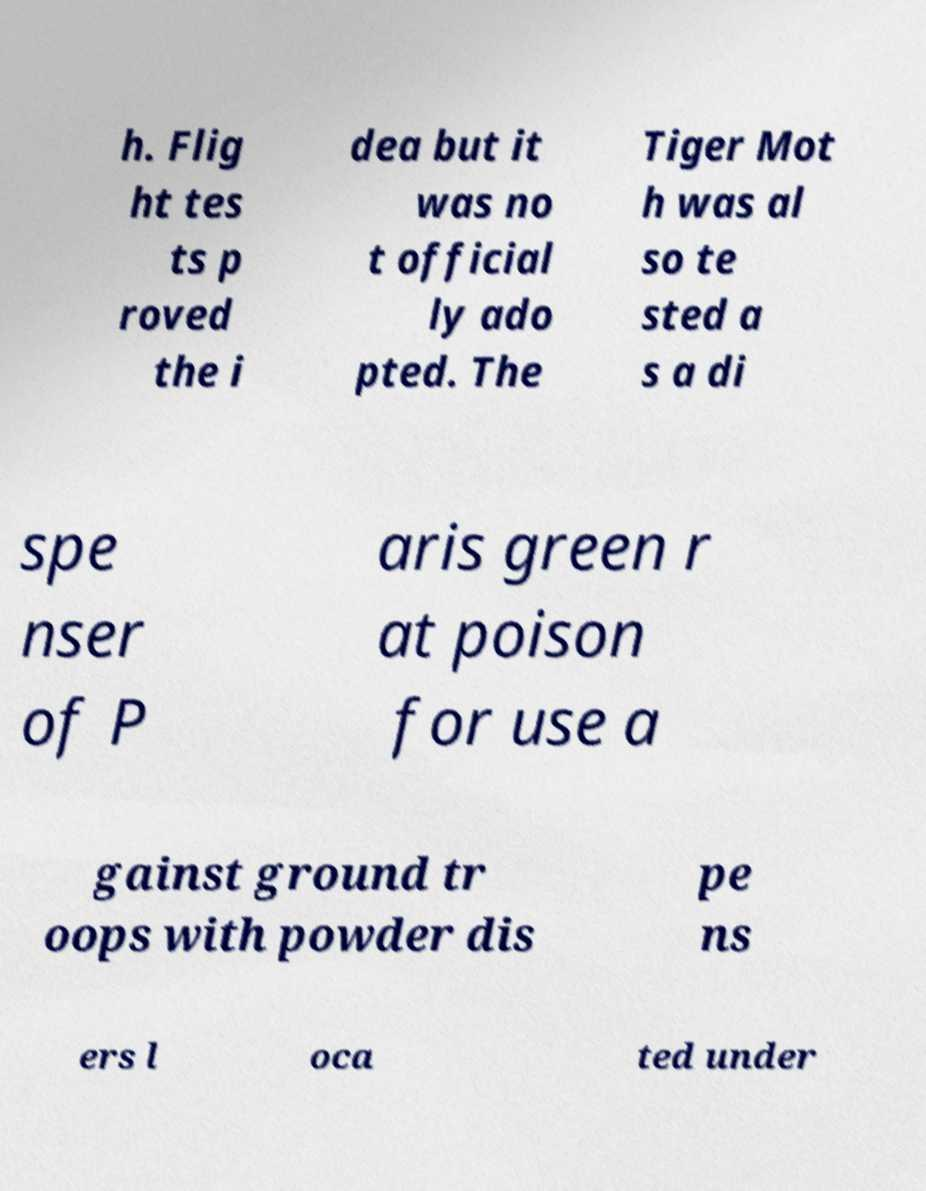Could you extract and type out the text from this image? h. Flig ht tes ts p roved the i dea but it was no t official ly ado pted. The Tiger Mot h was al so te sted a s a di spe nser of P aris green r at poison for use a gainst ground tr oops with powder dis pe ns ers l oca ted under 